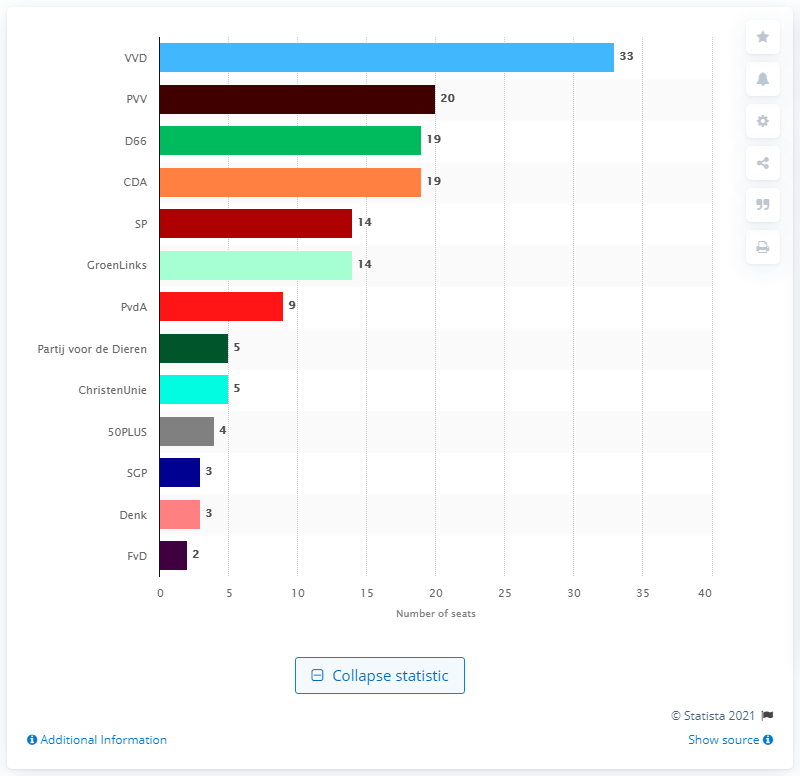Give some essential details in this illustration. Mark Rutte's VVD had 33 seats. 